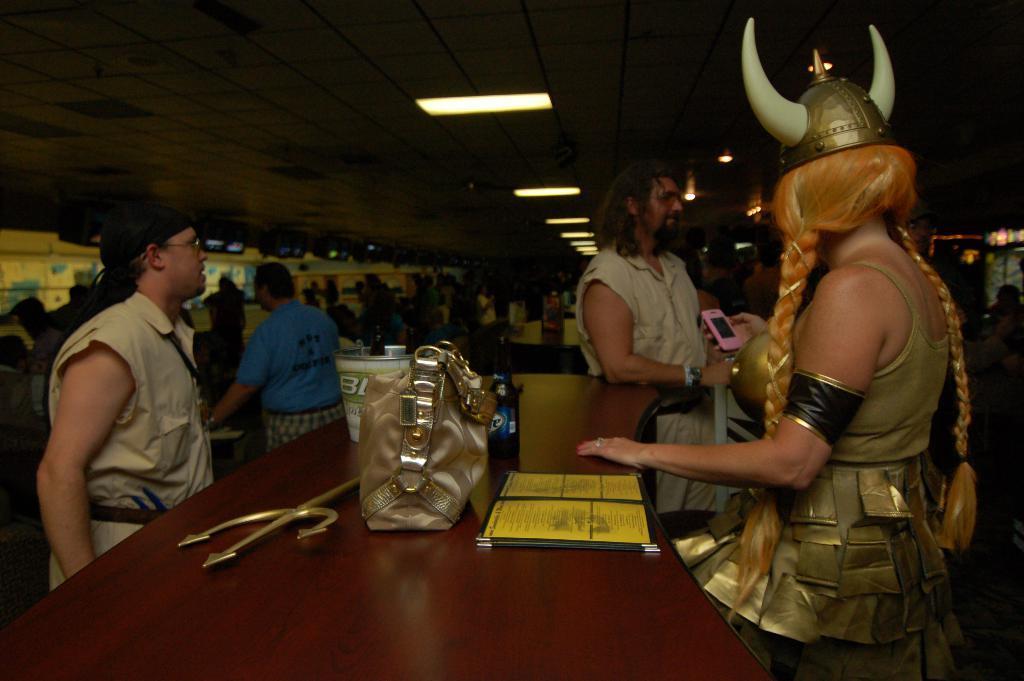Describe this image in one or two sentences. In this picture there are three people standing. A handbag, golden weapon, , bottle , box is visible on the table. There are some lights on the top. Few people are seen in the background. 